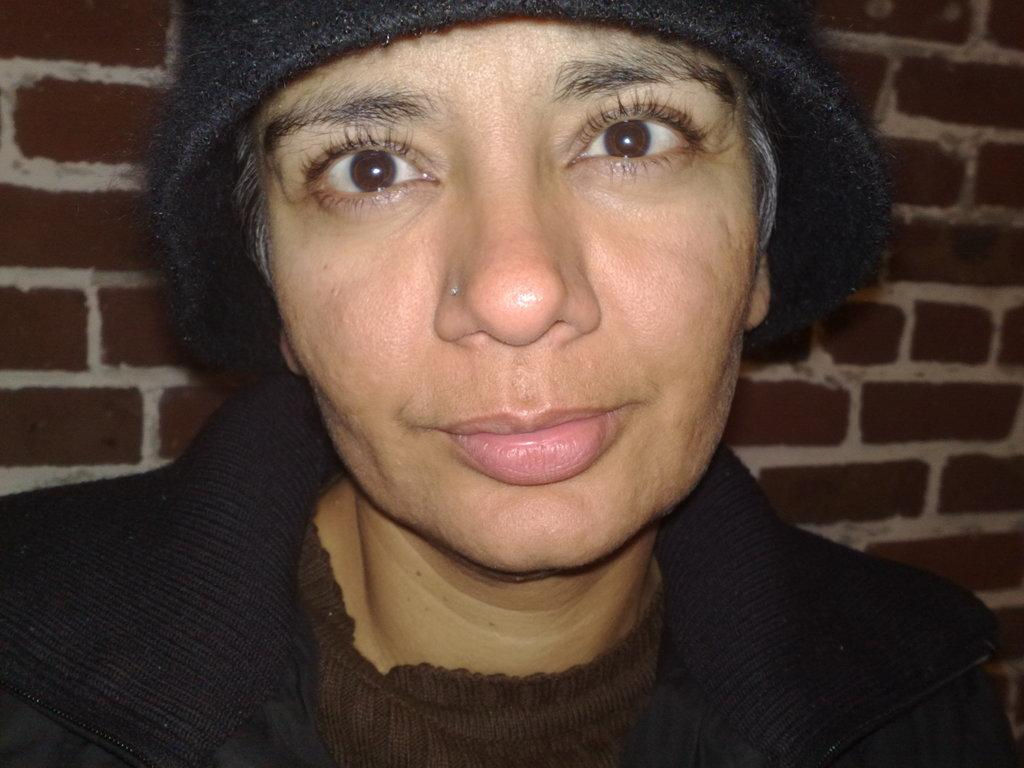What is the main subject of the image? The main subject of the image is a woman. What is the woman wearing on her head? The woman is wearing a cap. What expression does the woman have in the image? The woman is smiling. What can be seen in the background of the image? There is a wall in the background of the image. What type of engine can be seen powering the scarecrow in the image? There is no engine or scarecrow present in the image. How does the woman's smile affect her nerves in the image? The image does not provide information about the woman's nerves, so we cannot determine how her smile affects them. 